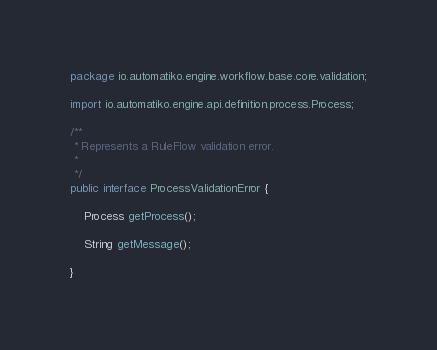Convert code to text. <code><loc_0><loc_0><loc_500><loc_500><_Java_>
package io.automatiko.engine.workflow.base.core.validation;

import io.automatiko.engine.api.definition.process.Process;

/**
 * Represents a RuleFlow validation error.
 * 
 */
public interface ProcessValidationError {

	Process getProcess();

	String getMessage();

}
</code> 